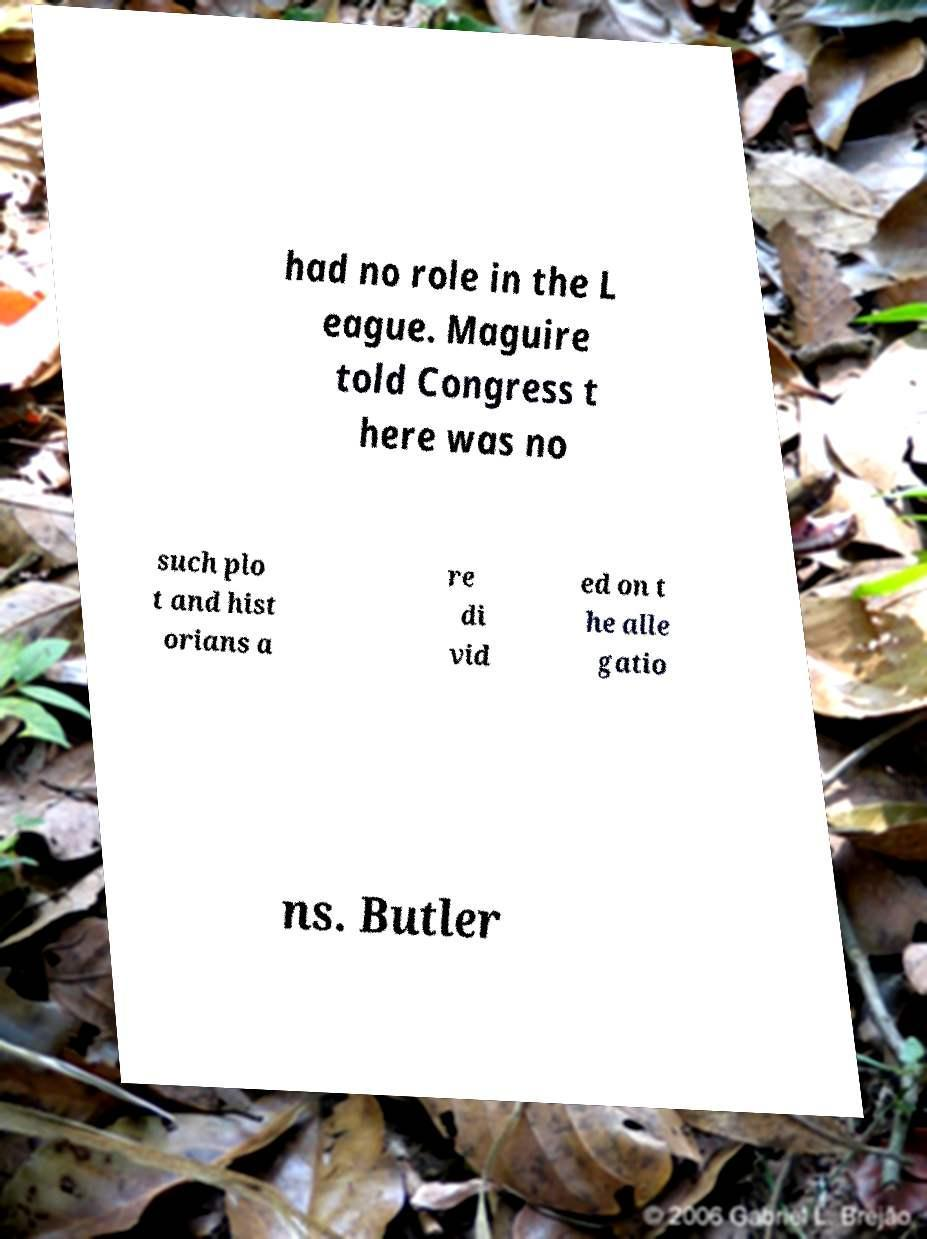There's text embedded in this image that I need extracted. Can you transcribe it verbatim? had no role in the L eague. Maguire told Congress t here was no such plo t and hist orians a re di vid ed on t he alle gatio ns. Butler 